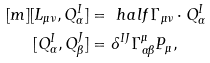Convert formula to latex. <formula><loc_0><loc_0><loc_500><loc_500>[ m ] [ L _ { \mu \nu } , Q ^ { I } _ { \alpha } ] & = \ h a l f \Gamma _ { \mu \nu } \cdot Q ^ { I } _ { \alpha } \\ [ Q ^ { I } _ { \alpha } , Q ^ { J } _ { \beta } ] & = \delta ^ { I J } \Gamma ^ { \mu } _ { \alpha \beta } P _ { \mu } ,</formula> 